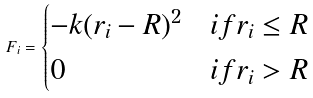<formula> <loc_0><loc_0><loc_500><loc_500>F _ { i } = \begin{cases} - k ( r _ { i } - R ) ^ { 2 } & i f r _ { i } \leq R \\ 0 & i f r _ { i } > R \end{cases}</formula> 